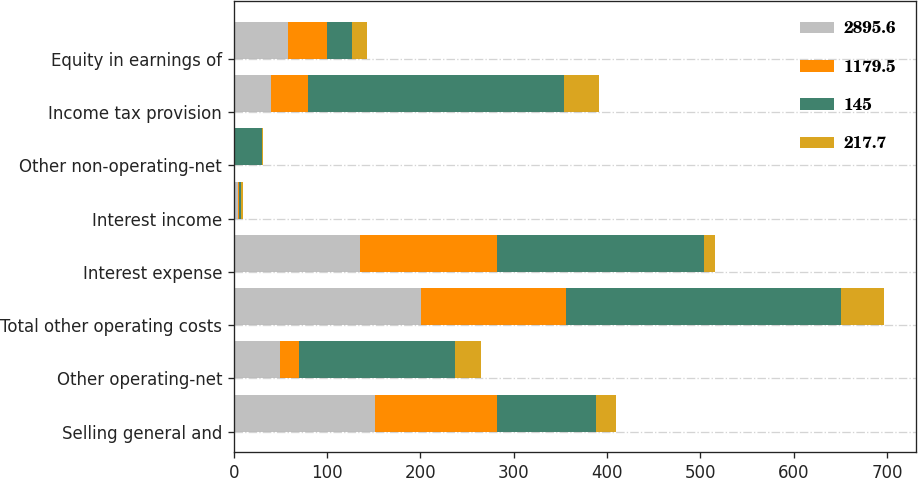Convert chart to OTSL. <chart><loc_0><loc_0><loc_500><loc_500><stacked_bar_chart><ecel><fcel>Selling general and<fcel>Other operating-net<fcel>Total other operating costs<fcel>Interest expense<fcel>Interest income<fcel>Other non-operating-net<fcel>Income tax provision<fcel>Equity in earnings of<nl><fcel>2895.6<fcel>151.8<fcel>49.1<fcel>200.9<fcel>135.3<fcel>4.3<fcel>1.1<fcel>39.8<fcel>58.1<nl><fcel>1179.5<fcel>130<fcel>20.9<fcel>155.3<fcel>147.2<fcel>1.7<fcel>0.6<fcel>39.8<fcel>41.9<nl><fcel>145<fcel>106.1<fcel>166.7<fcel>294.4<fcel>221.3<fcel>1.5<fcel>28.8<fcel>273.7<fcel>26.7<nl><fcel>217.7<fcel>21.8<fcel>28.2<fcel>45.6<fcel>11.9<fcel>2.6<fcel>0.5<fcel>37.7<fcel>16.2<nl></chart> 